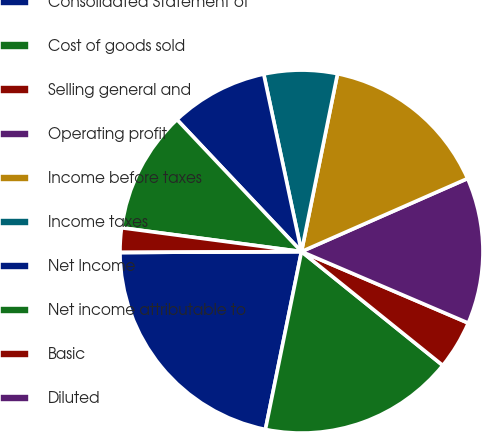Convert chart. <chart><loc_0><loc_0><loc_500><loc_500><pie_chart><fcel>Consolidated Statement of<fcel>Cost of goods sold<fcel>Selling general and<fcel>Operating profit<fcel>Income before taxes<fcel>Income taxes<fcel>Net Income<fcel>Net income attributable to<fcel>Basic<fcel>Diluted<nl><fcel>21.74%<fcel>17.39%<fcel>4.35%<fcel>13.04%<fcel>15.22%<fcel>6.52%<fcel>8.7%<fcel>10.87%<fcel>2.17%<fcel>0.0%<nl></chart> 